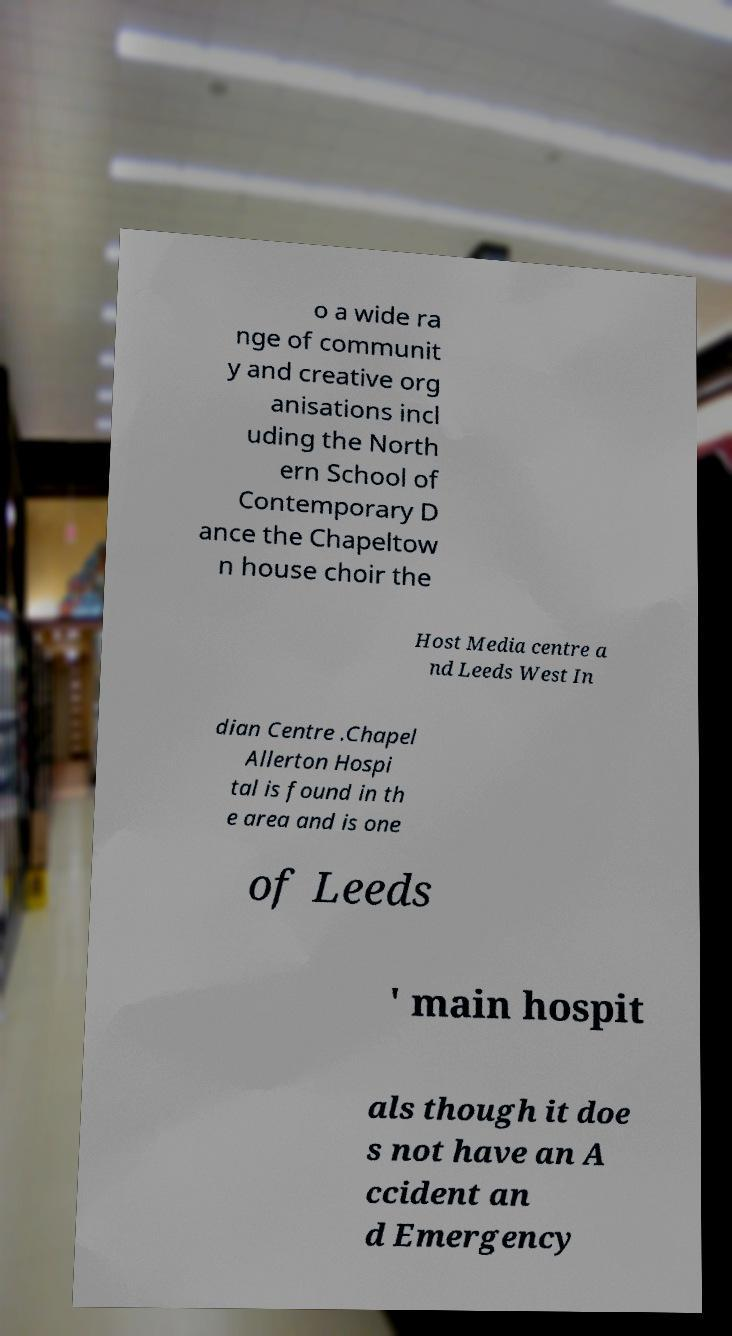Could you extract and type out the text from this image? o a wide ra nge of communit y and creative org anisations incl uding the North ern School of Contemporary D ance the Chapeltow n house choir the Host Media centre a nd Leeds West In dian Centre .Chapel Allerton Hospi tal is found in th e area and is one of Leeds ' main hospit als though it doe s not have an A ccident an d Emergency 